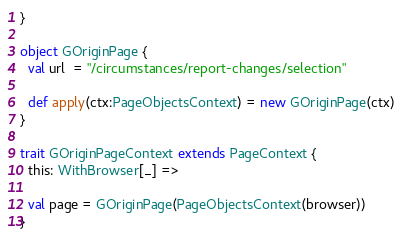<code> <loc_0><loc_0><loc_500><loc_500><_Scala_>}

object GOriginPage {
  val url  = "/circumstances/report-changes/selection"

  def apply(ctx:PageObjectsContext) = new GOriginPage(ctx)
}

trait GOriginPageContext extends PageContext {
  this: WithBrowser[_] =>

  val page = GOriginPage(PageObjectsContext(browser))
}

</code> 